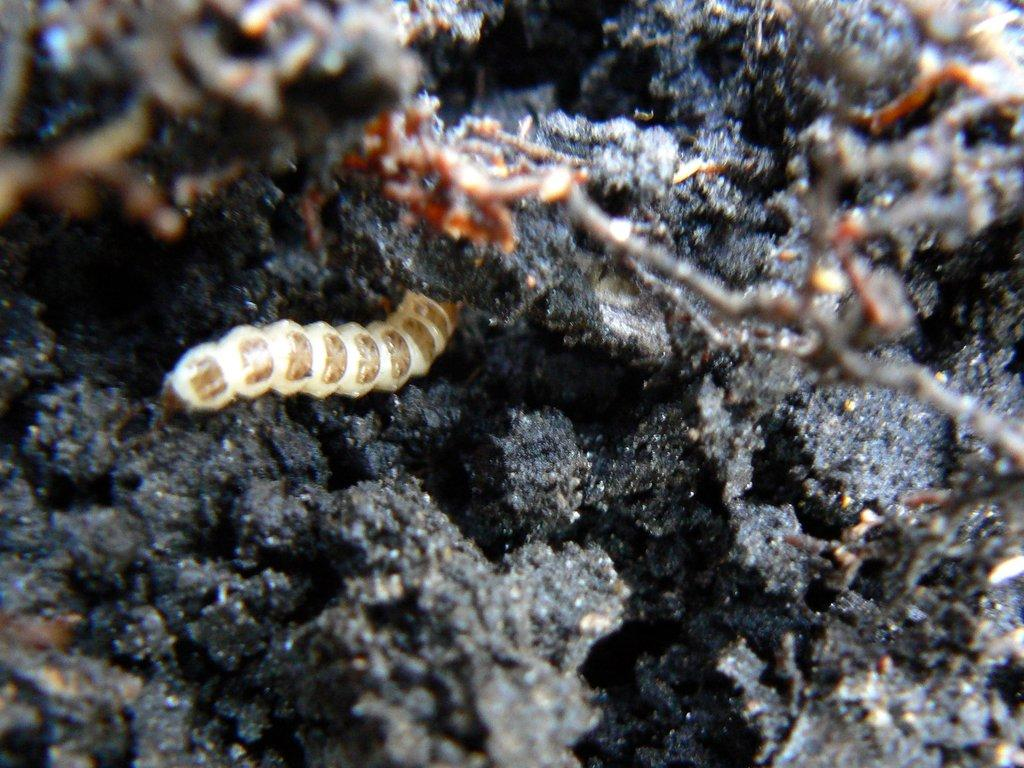What type of creature can be seen in the image? There is an insect in the image. Where is the insect located? The insect is on a rock. What type of parcel is being delivered by the insect in the image? There is no parcel present in the image, and the insect is not delivering anything. 